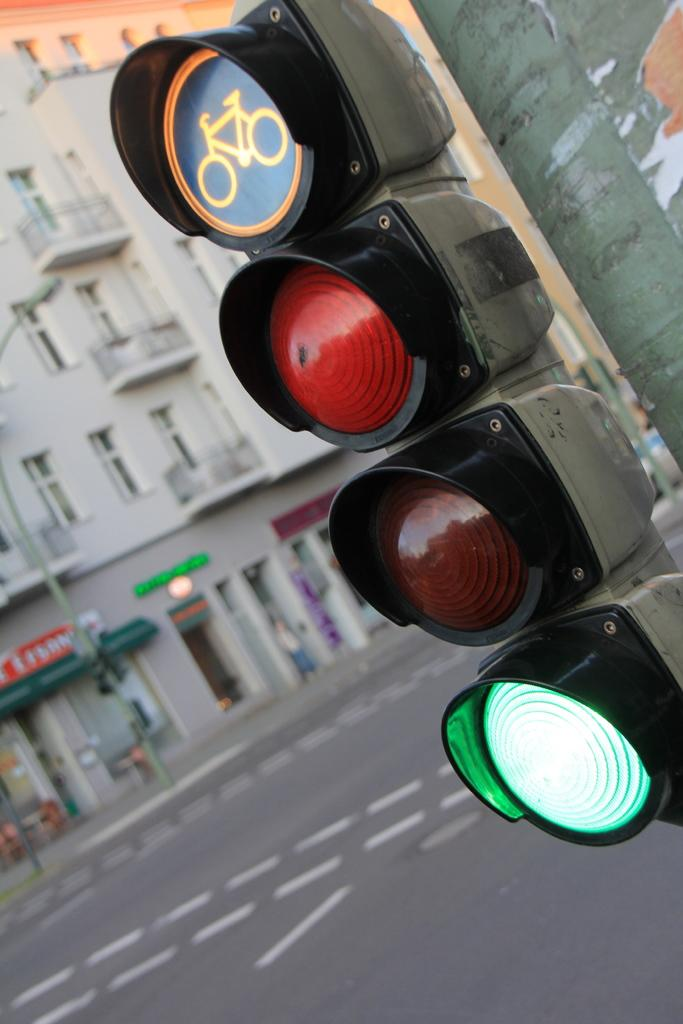What type of structure is visible in the image? There is a building in the image. What feature can be seen on the building? The building has windows. What else is present in the image besides the building? There is a road and traffic lights in the image. What type of knowledge can be gained from the beast in the image? There is no beast present in the image, so no knowledge can be gained from it. 